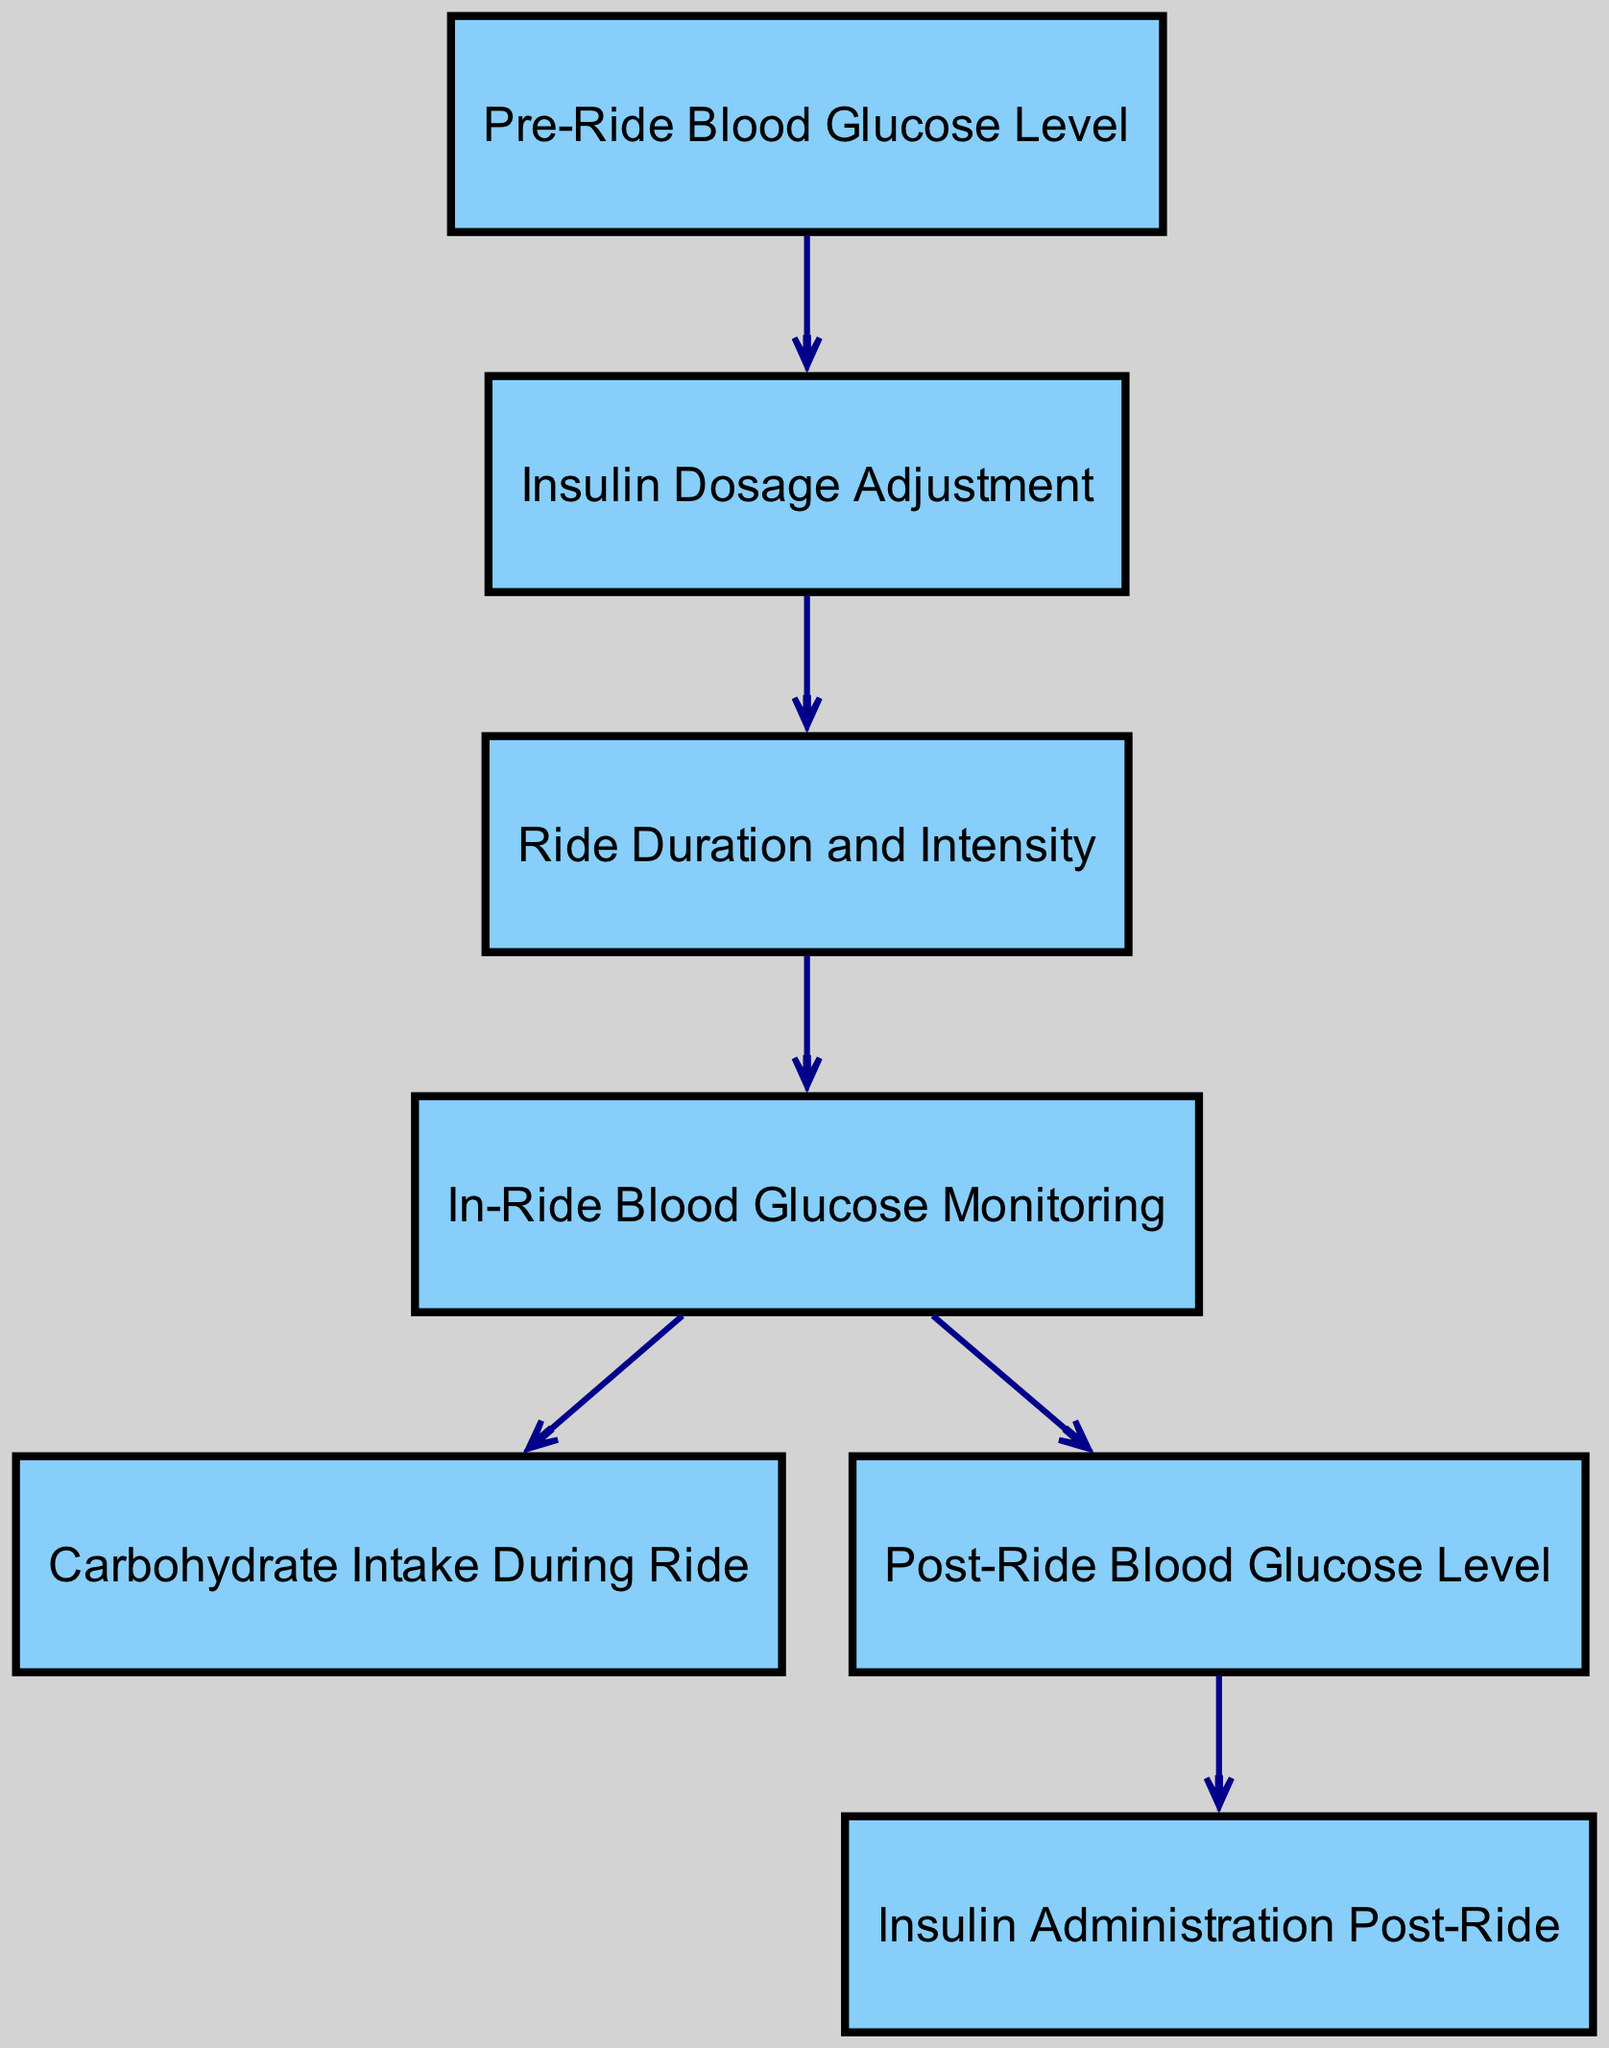What is the first node in the diagram? The first node in the diagram is labeled "Pre-Ride Blood Glucose Level." It is the starting point of the directed graph and indicates where the process begins.
Answer: Pre-Ride Blood Glucose Level What is the relationship between node 1 and node 2? Node 1 ("Pre-Ride Blood Glucose Level") leads to node 2 ("Insulin Dosage Adjustment"). This means that the pre-ride blood glucose level influences how much insulin dosage needs to be adjusted.
Answer: leads to How many nodes are present in the diagram? The diagram contains a total of seven nodes, which represent various stages in tracking blood glucose and adjusting insulin.
Answer: 7 What happens after monitoring blood glucose levels in-ride? After monitoring blood glucose levels in-ride (node 4), the next nodes involve both carbohydrate intake (node 5) and the measurement of post-ride blood glucose (node 6). This indicates simultaneous actions post-monitoring.
Answer: Carbohydrate Intake During Ride and Post-Ride Blood Glucose Level What is the last step in the insulin adjustment process? The last step indicated in the diagram is "Insulin Administration Post-Ride." This is the final action taken after evaluating the post-ride blood glucose level.
Answer: Insulin Administration Post-Ride How does insulin dosage adjustment influence ride preparation? Insulin dosage adjustment is directly influenced by the pre-ride blood glucose level (node 1), meaning this adjustment is necessary based on initial glucose readings before starting the ride.
Answer: by Pre-Ride Blood Glucose Level How many edges are present in the diagram? The diagram has six edges that represent the connections or relationships between the different nodes, showing the flow of information.
Answer: 6 What type of intake can affect in-ride blood glucose levels? The in-ride blood glucose levels can be affected by "Carbohydrate Intake During Ride." This shows the interactive relationship between carbohydrate intake and blood glucose management during cycling.
Answer: Carbohydrate Intake During Ride 